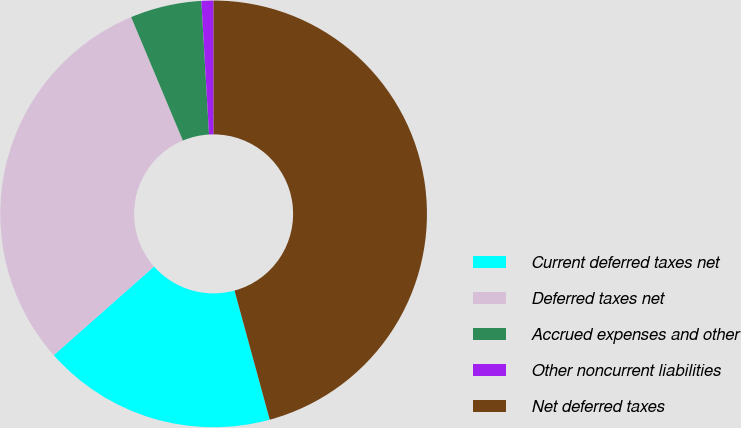<chart> <loc_0><loc_0><loc_500><loc_500><pie_chart><fcel>Current deferred taxes net<fcel>Deferred taxes net<fcel>Accrued expenses and other<fcel>Other noncurrent liabilities<fcel>Net deferred taxes<nl><fcel>17.72%<fcel>30.2%<fcel>5.4%<fcel>0.91%<fcel>45.76%<nl></chart> 